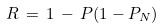Convert formula to latex. <formula><loc_0><loc_0><loc_500><loc_500>R \, = \, 1 \, - \, P ( 1 - P _ { N } )</formula> 